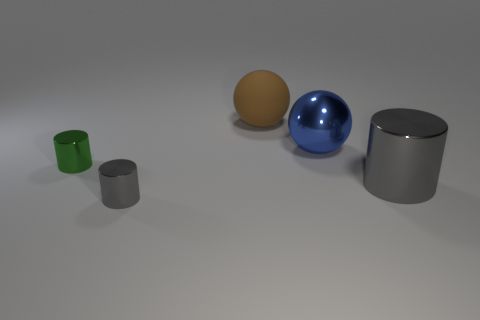Add 4 gray metal things. How many objects exist? 9 Subtract all brown spheres. How many spheres are left? 1 Subtract all gray cylinders. How many cylinders are left? 1 Subtract 1 cylinders. How many cylinders are left? 2 Add 1 big blue matte blocks. How many big blue matte blocks exist? 1 Subtract 0 brown cylinders. How many objects are left? 5 Subtract all spheres. How many objects are left? 3 Subtract all purple balls. Subtract all brown cylinders. How many balls are left? 2 Subtract all blue cubes. How many green cylinders are left? 1 Subtract all brown rubber objects. Subtract all gray cylinders. How many objects are left? 2 